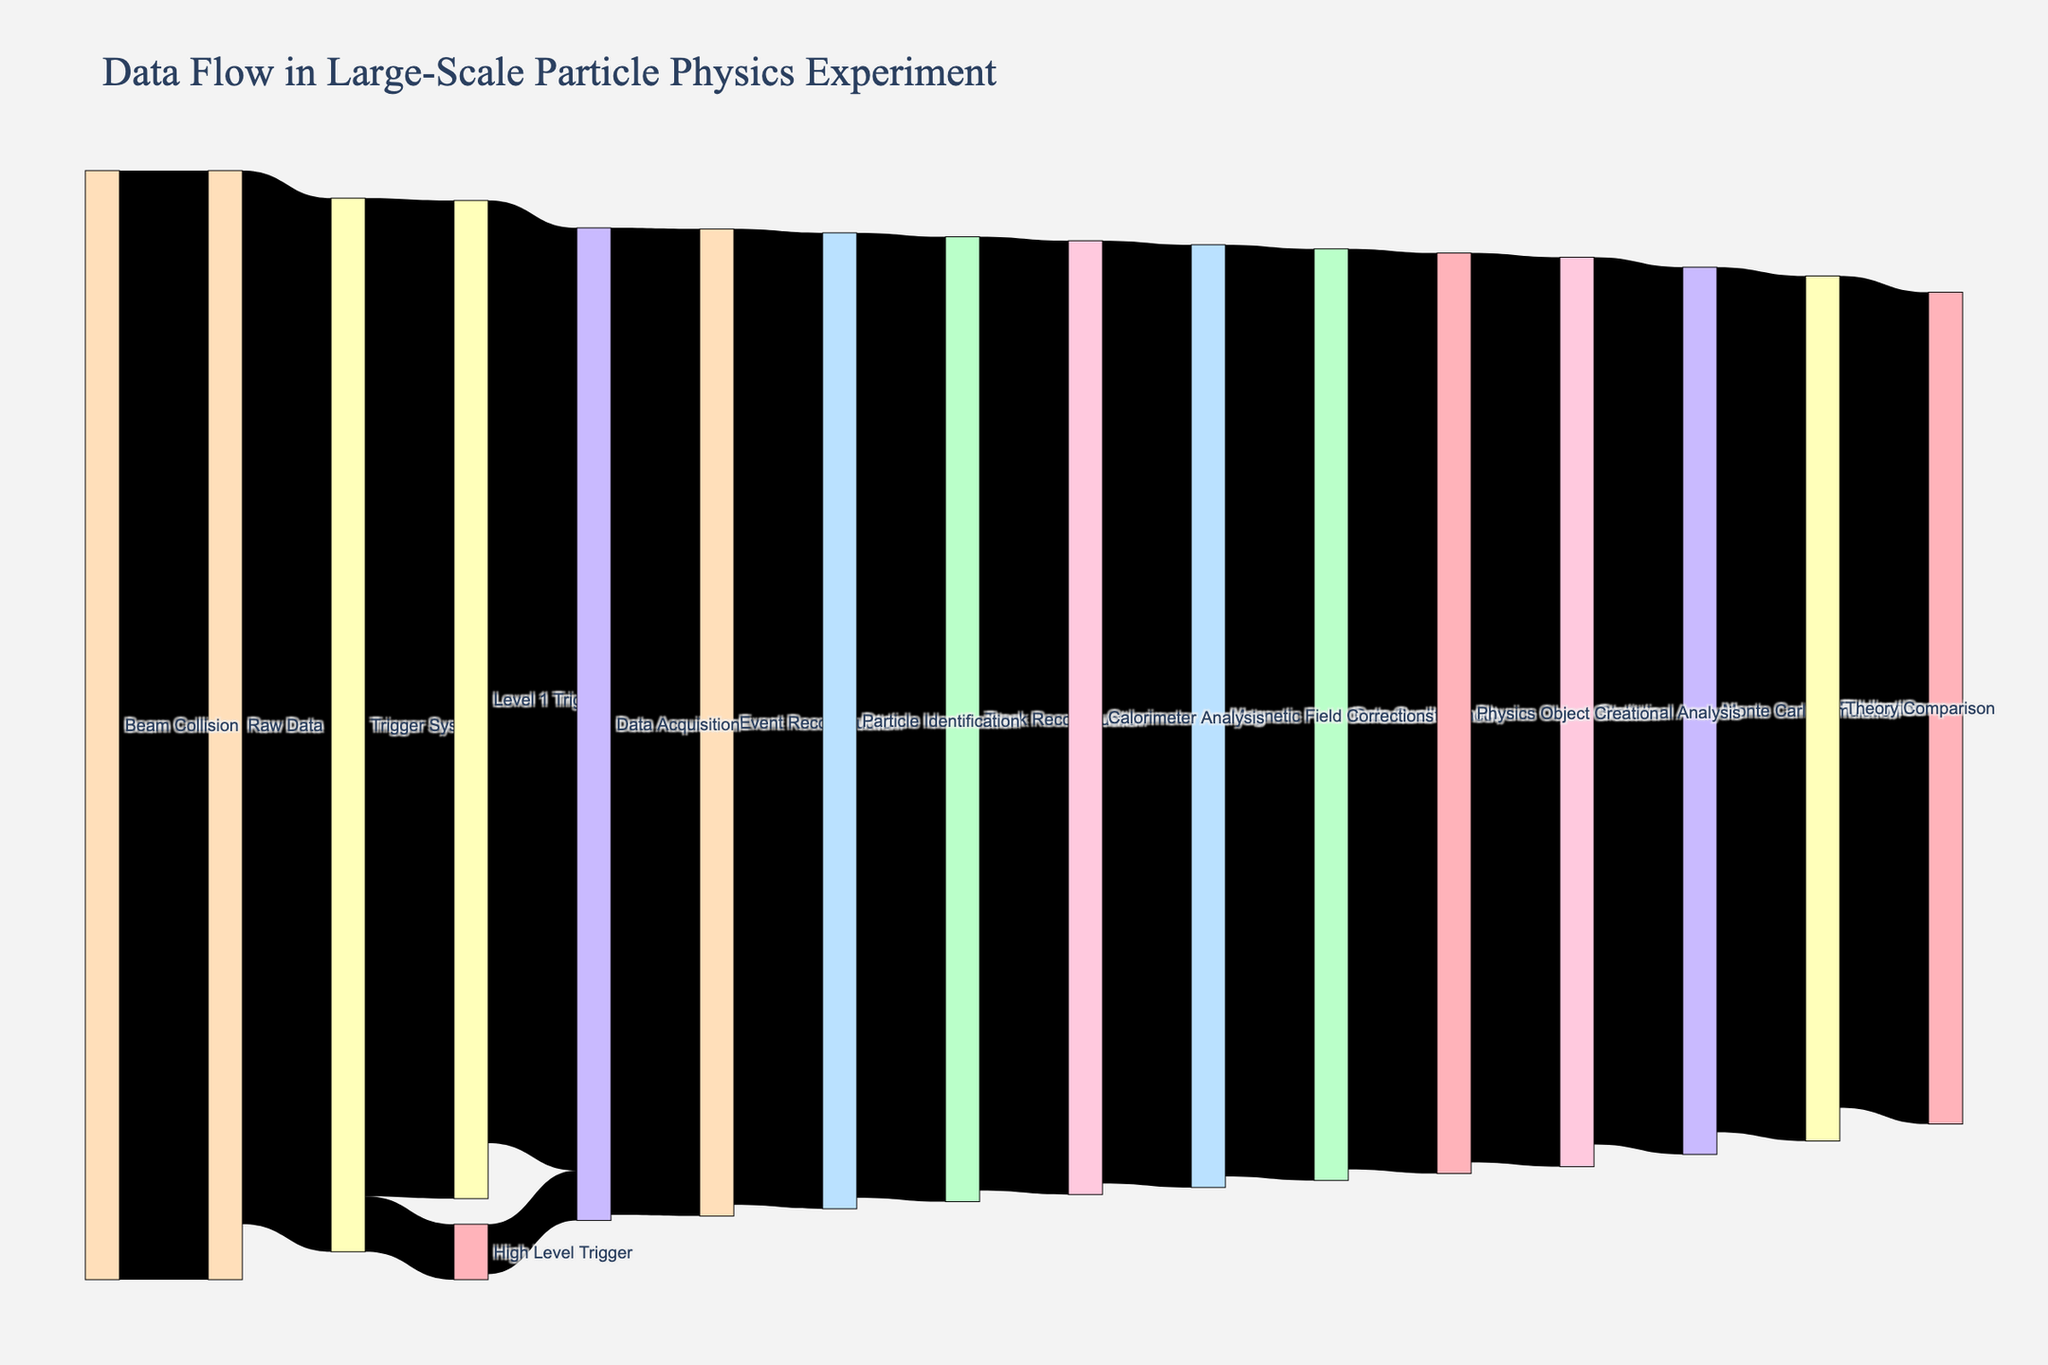What is the title of the Sankey diagram? The title is located at the top of the diagram and typically provides a summary of the content or focus of the chart. In this diagram, the title reads "Data Flow in Large-Scale Particle Physics Experiment".
Answer: Data Flow in Large-Scale Particle Physics Experiment How many levels of triggers are there in the trigger system? By observing the connections coming out of the "Trigger System" node, we can see it branches into "Level 1 Trigger" and "High Level Trigger". Therefore, there are two levels of triggers.
Answer: 2 What is the total value of data that reaches the Data Acquisition step? From the diagram, the Data Acquisition step receives data from both "Level 1 Trigger" and "High Level Trigger". The values are 85,000 and 4,500 respectively. Summing these two values gives 85,000 + 4,500 = 89,500.
Answer: 89,500 Which stage in the process has the lowest value? By examining all the values associated with each stage, "High Level Trigger" with a value of 4,500 is the lowest.
Answer: High Level Trigger What is the value of data that undergoes Statistical Analysis? The data reaching the "Statistical Analysis" node comes from "Physics Object Creation" with a value of 82,000. This value can be directly read from the diagram.
Answer: 82,000 How many stages are involved from "Raw Data" to "Publication"? Starting from "Raw Data", follow the path: "Raw Data" → "Trigger System" → "Level 1 Trigger" → "Data Acquisition" → "Event Reconstruction" → "Particle Identification" → "Track Reconstruction" → "Calorimeter Analysis" → "Magnetic Field Corrections" → "Data Quality Check" → "Physics Object Creation" → "Statistical Analysis" → "Monte Carlo Simulation" → "Theory Comparison" → "Publication". Counting these stages, we get 15 stages.
Answer: 15 Compare the data loss from "Beam Collision" to "Trigger System" with the data loss from "Trigger System" to "High Level Trigger". "Beam Collision" to "Trigger System" has a loss of 100,000 - 95,000 = 5,000. "Trigger System" to "High Level Trigger" has a value of 5,000. Hence, both have a data loss of 5,000.
Answer: 5,000 for both What is the final value of data that results in publication? The "Publication" node receives a value of 75,000 from the "Theory Comparison" stage, which can be directly read from the diagram.
Answer: 75,000 How much data is filtered out between the "Raw Data" and "Level 1 Trigger" stages? From "Raw Data" to "Trigger System": 100,000 - 95,000 = 5,000. From "Trigger System" to "Level 1 Trigger": 95,000 - 90,000 = 5,000. Summing these losses, 5,000 + 5,000 = 10,000.
Answer: 10,000 